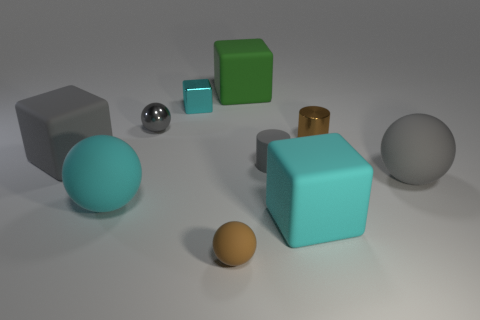Are there an equal number of tiny gray metallic objects behind the cyan metal cube and small brown rubber balls?
Make the answer very short. No. What is the material of the brown object on the right side of the cyan object to the right of the cylinder on the left side of the small brown shiny thing?
Offer a terse response. Metal. What is the shape of the tiny gray thing that is made of the same material as the green object?
Offer a very short reply. Cylinder. Are there any other things that are the same color as the metallic cube?
Your response must be concise. Yes. How many large green objects are on the left side of the big rubber object behind the cyan thing that is behind the small gray shiny ball?
Provide a succinct answer. 0. What number of purple objects are either balls or metallic cylinders?
Offer a very short reply. 0. There is a shiny ball; is it the same size as the matte block behind the large gray matte block?
Provide a short and direct response. No. What is the material of the brown thing that is the same shape as the gray metallic thing?
Provide a succinct answer. Rubber. How many other things are there of the same size as the gray shiny object?
Provide a short and direct response. 4. What is the shape of the tiny thing that is in front of the large gray matte thing that is on the right side of the small matte thing that is on the left side of the gray matte cylinder?
Give a very brief answer. Sphere. 